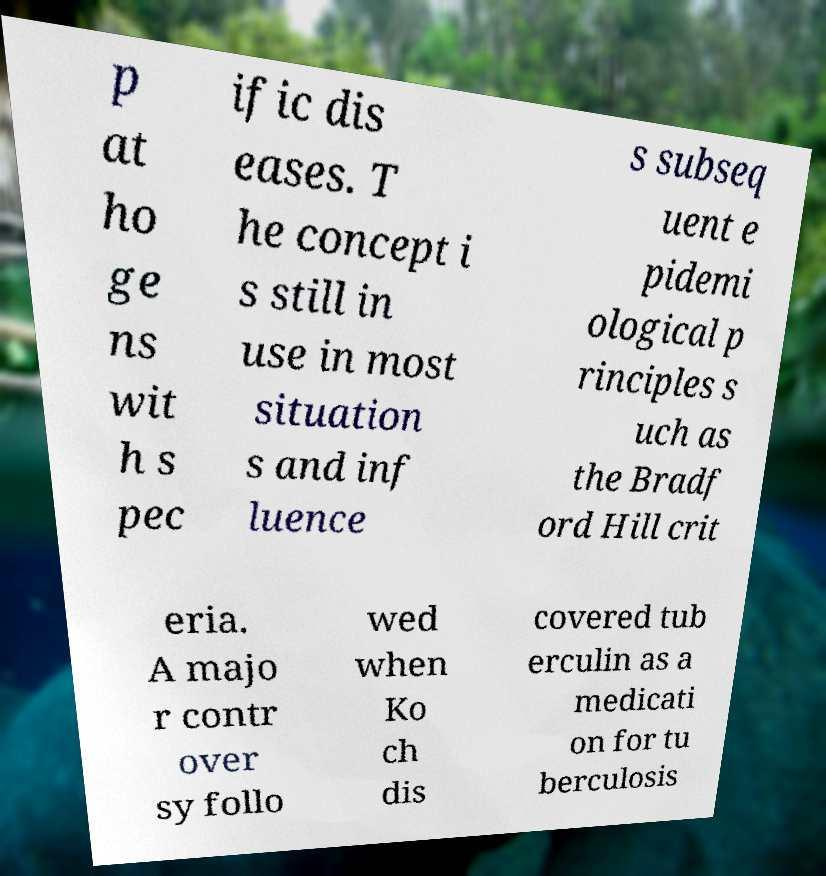Can you read and provide the text displayed in the image?This photo seems to have some interesting text. Can you extract and type it out for me? p at ho ge ns wit h s pec ific dis eases. T he concept i s still in use in most situation s and inf luence s subseq uent e pidemi ological p rinciples s uch as the Bradf ord Hill crit eria. A majo r contr over sy follo wed when Ko ch dis covered tub erculin as a medicati on for tu berculosis 